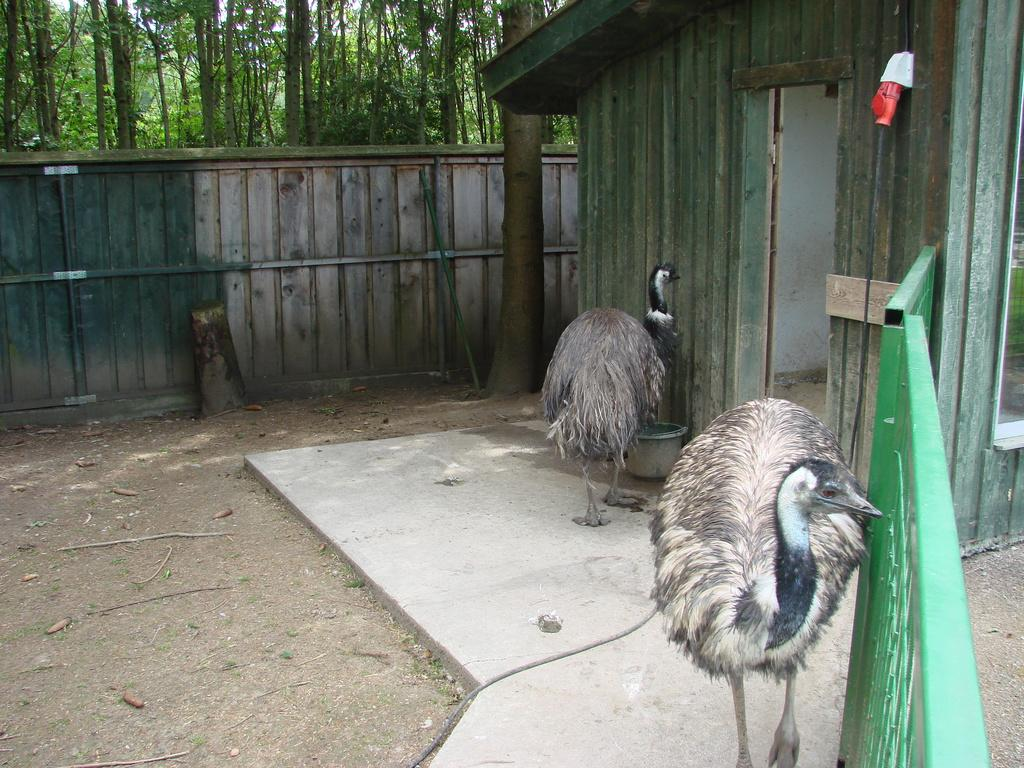How many ostriches are in the image? There are two ostriches in the image. Where are the ostriches located? The ostriches are on a path in the image. What else can be seen in the image besides the ostriches? There is a container, a shed, a fence, a wall, some objects, and trees in the background of the image. What type of spring is used to power the ostriches' movements in the image? There is no spring or any mechanical device present in the image; the ostriches are real animals. What current event is being depicted in the image? The image does not depict any current event; it simply shows two ostriches on a path with other elements in the background. 